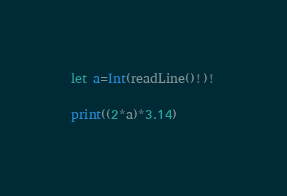<code> <loc_0><loc_0><loc_500><loc_500><_Swift_>let a=Int(readLine()!)!

print((2*a)*3.14)</code> 